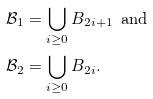<formula> <loc_0><loc_0><loc_500><loc_500>\mathcal { B } _ { 1 } & = \bigcup _ { i \geq 0 } B _ { 2 i + 1 } \text {\, and} \\ \mathcal { B } _ { 2 } & = \bigcup _ { i \geq 0 } B _ { 2 i } .</formula> 